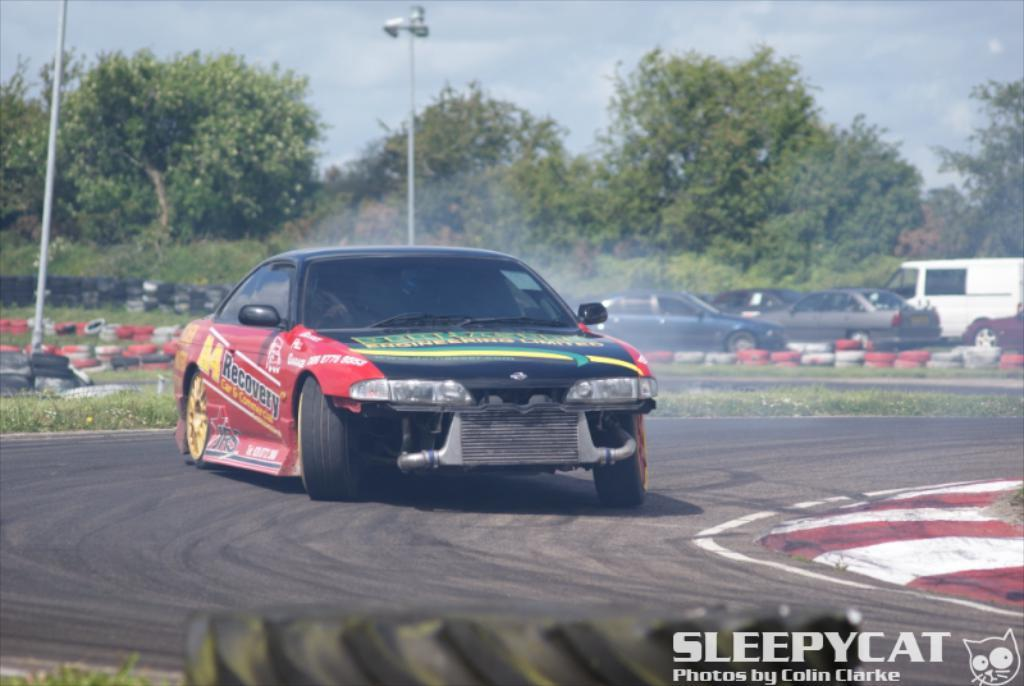What type of vehicle is in the foreground of the image? There is a sports car on the road in the foreground of the image. What can be found at the bottom side of the image? There is text at the bottom side of the image. What can be seen in the background of the image? There are vehicles, tires, trees, poles, and the sky visible in the background of the image. What type of quartz can be seen in the image? There is no quartz present in the image. Is it raining in the image? The image does not provide any information about the weather, so we cannot determine if it is raining or not. 